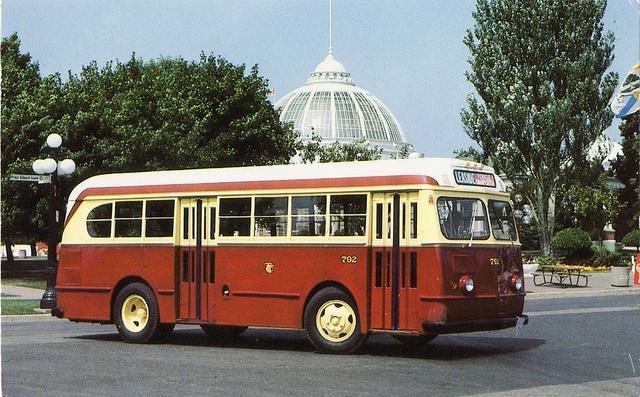Is this a new bus?
Short answer required. No. What kind of vehicle is this?
Write a very short answer. Bus. How many wheels does the bus have?
Be succinct. 4. 